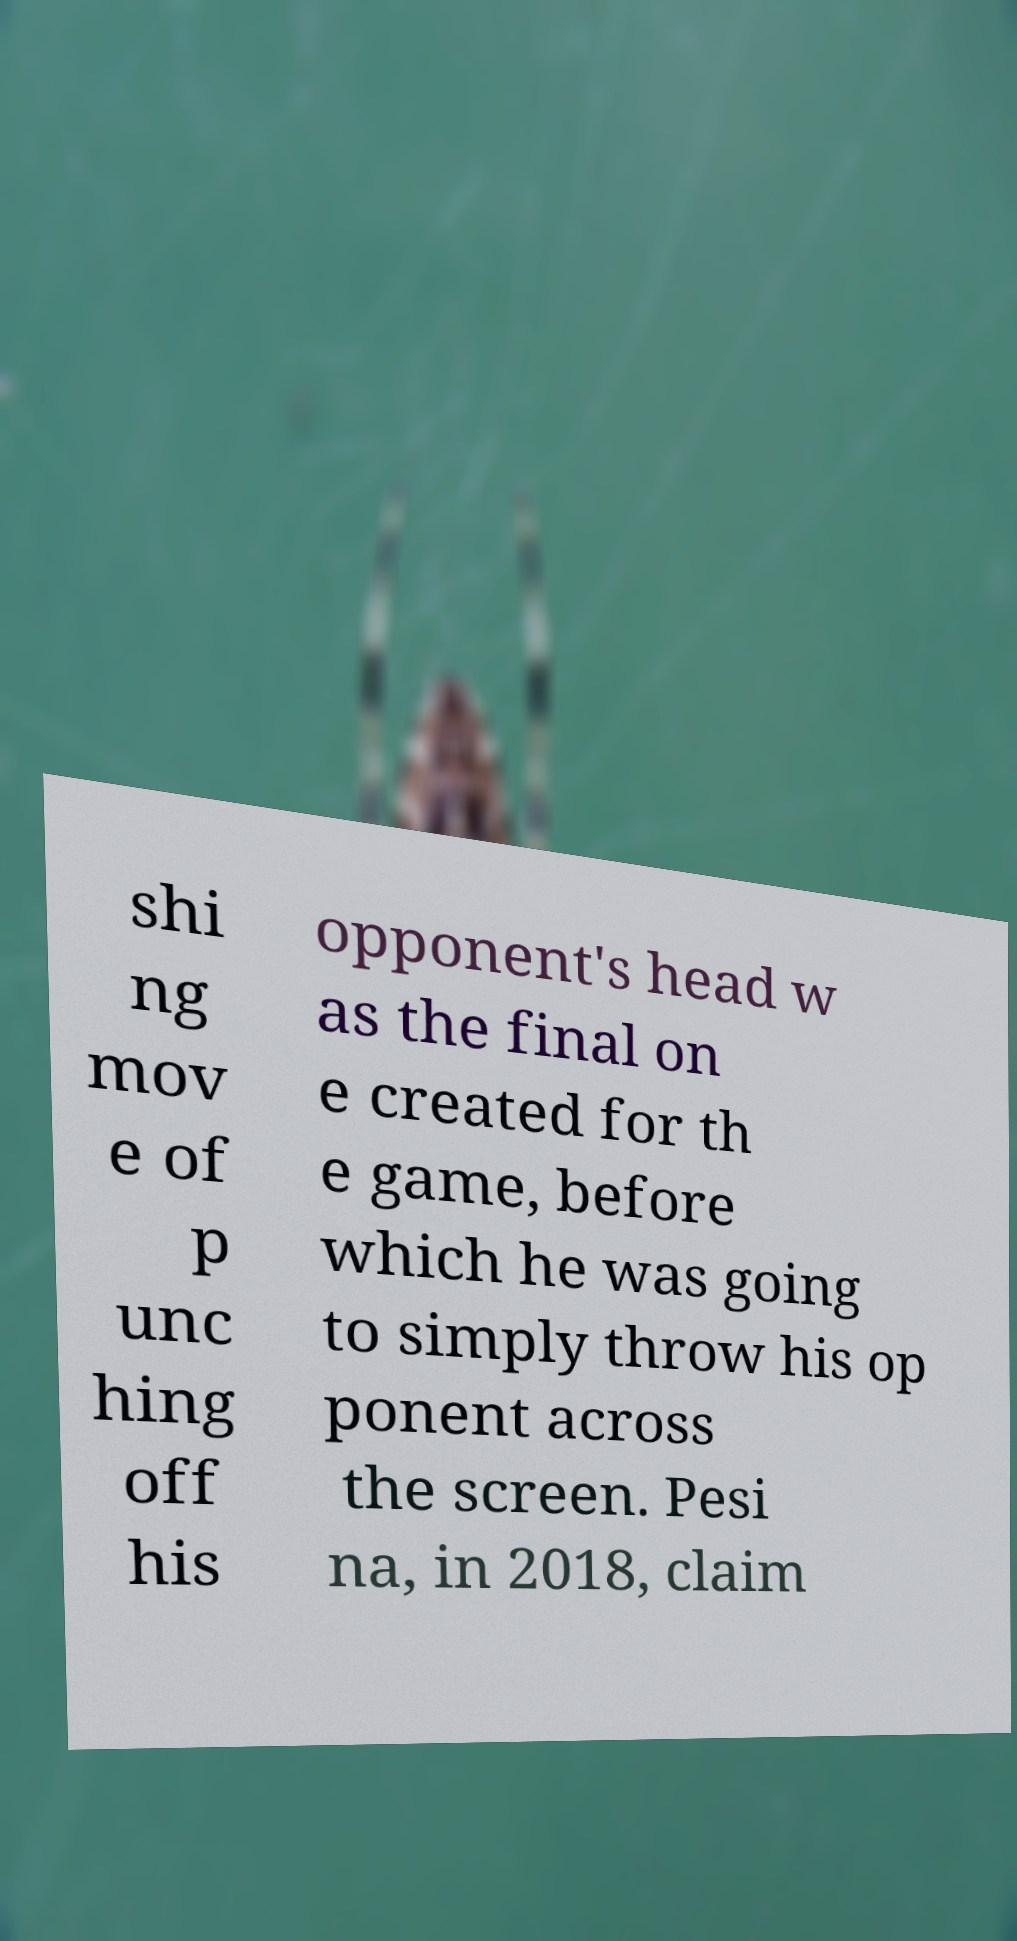I need the written content from this picture converted into text. Can you do that? shi ng mov e of p unc hing off his opponent's head w as the final on e created for th e game, before which he was going to simply throw his op ponent across the screen. Pesi na, in 2018, claim 